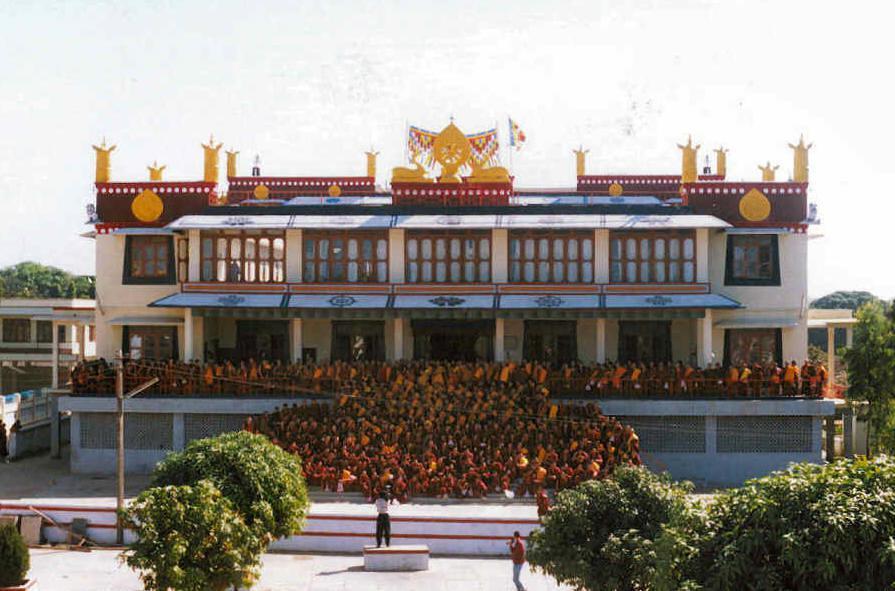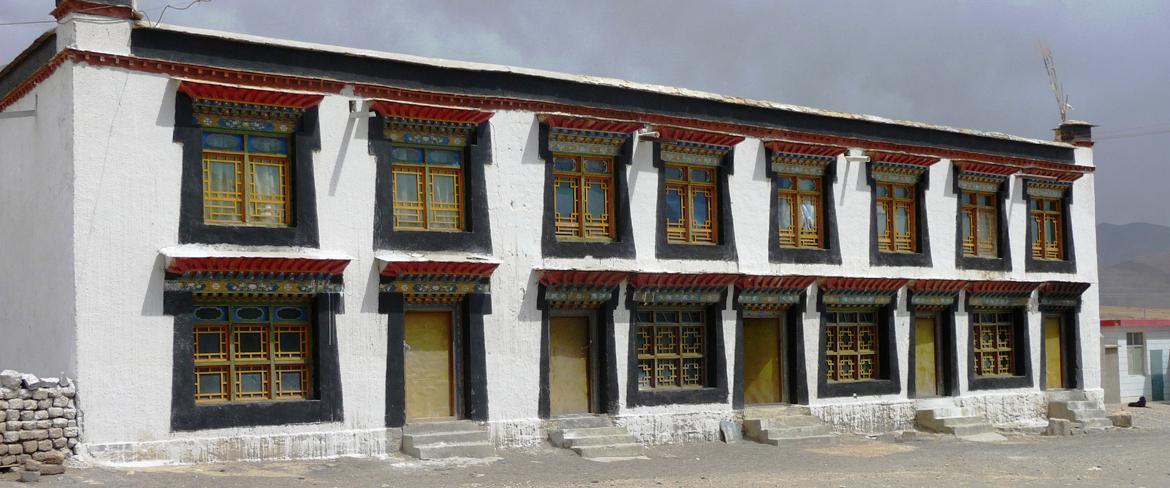The first image is the image on the left, the second image is the image on the right. For the images displayed, is the sentence "To the right, we see a blue sky, with no clouds, behind the building." factually correct? Answer yes or no. No. The first image is the image on the left, the second image is the image on the right. For the images shown, is this caption "Both images contain one single building, made of mostly right angles." true? Answer yes or no. Yes. 